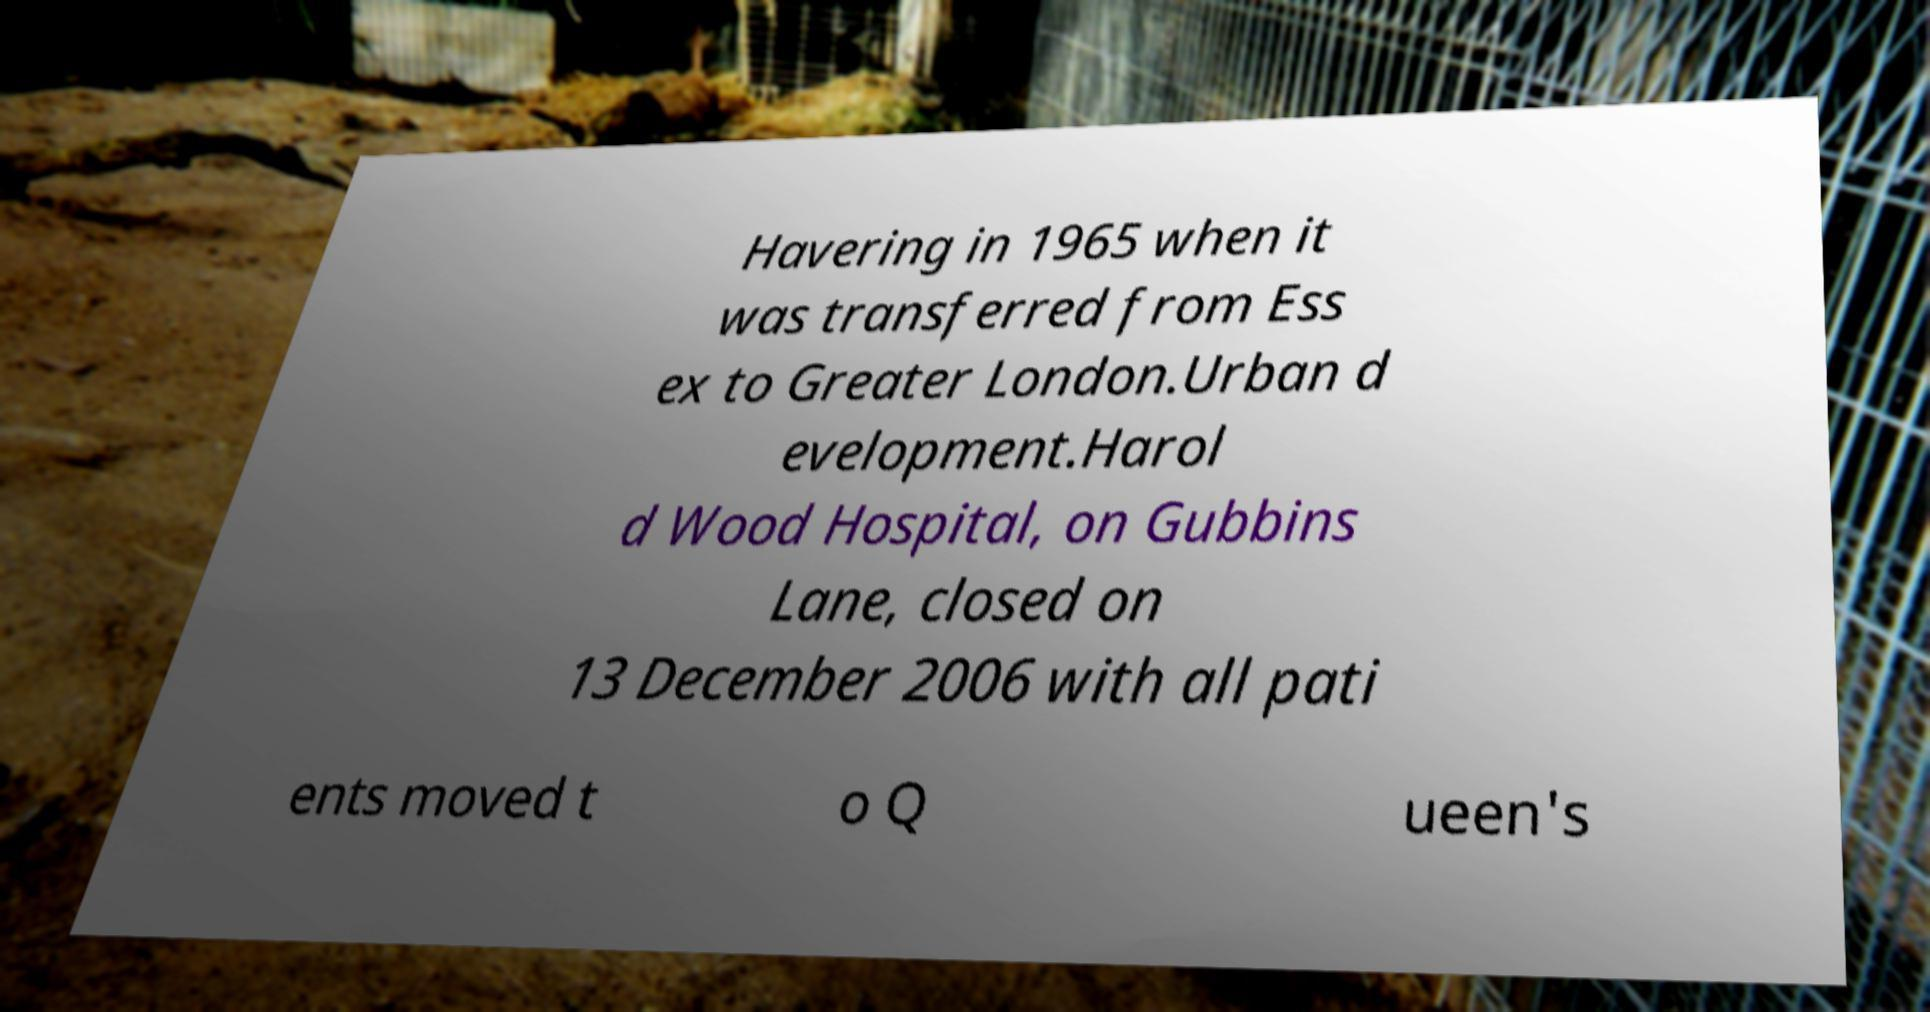Can you read and provide the text displayed in the image?This photo seems to have some interesting text. Can you extract and type it out for me? Havering in 1965 when it was transferred from Ess ex to Greater London.Urban d evelopment.Harol d Wood Hospital, on Gubbins Lane, closed on 13 December 2006 with all pati ents moved t o Q ueen's 